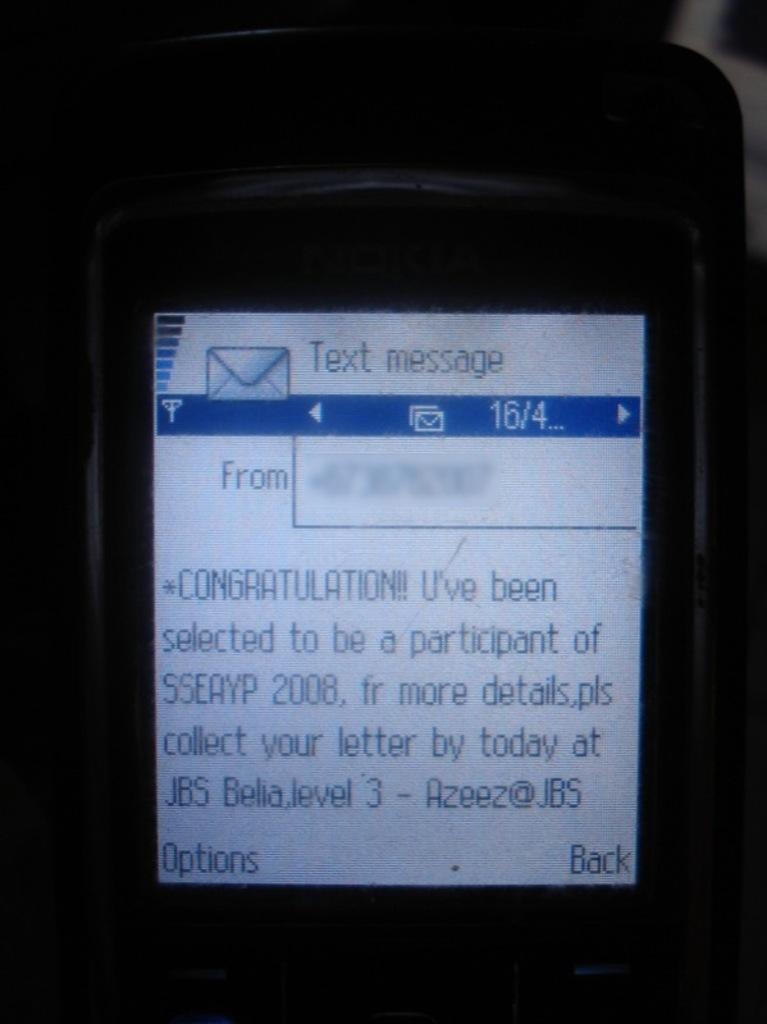Who is the text from?
Your answer should be compact. Unanswerable. What year is shown in this message?
Make the answer very short. 2008. 